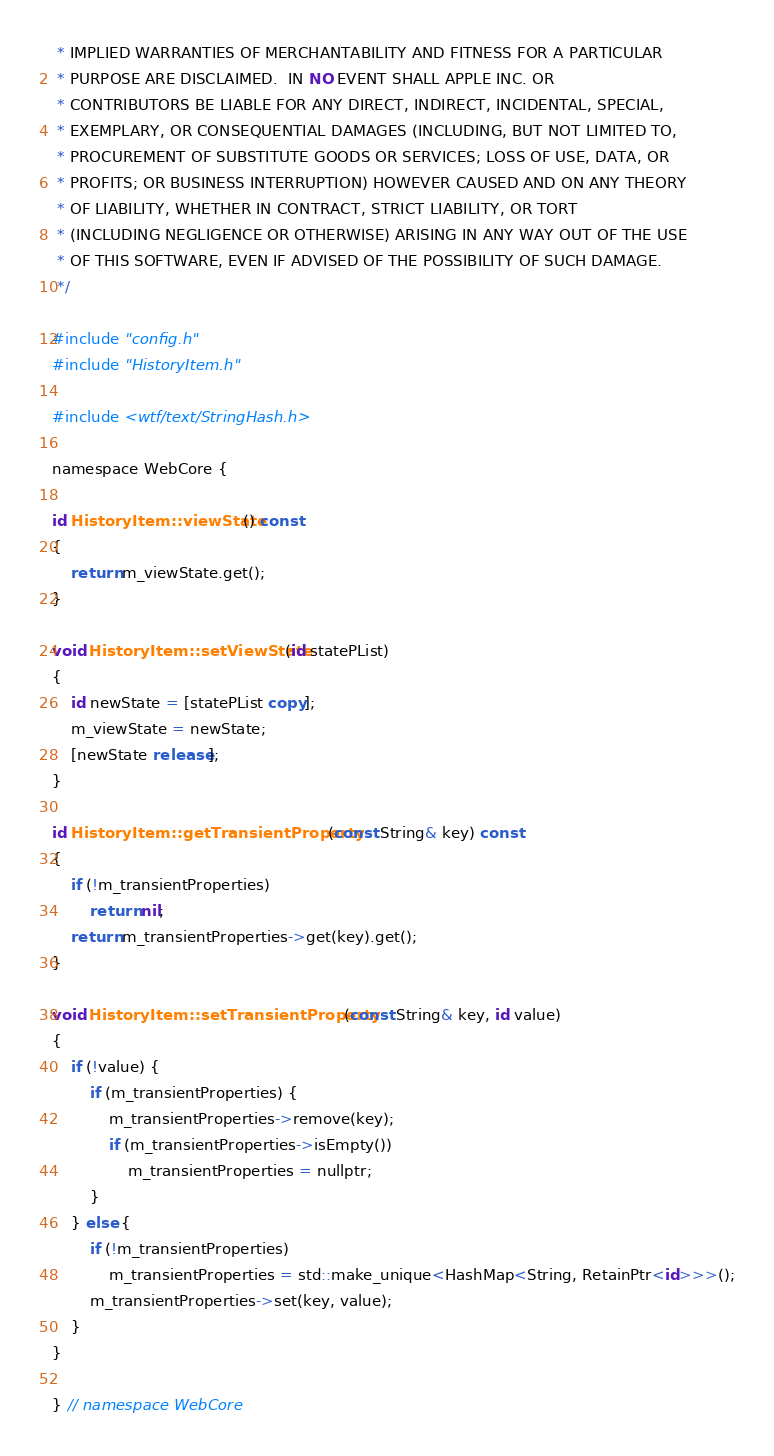<code> <loc_0><loc_0><loc_500><loc_500><_ObjectiveC_> * IMPLIED WARRANTIES OF MERCHANTABILITY AND FITNESS FOR A PARTICULAR
 * PURPOSE ARE DISCLAIMED.  IN NO EVENT SHALL APPLE INC. OR
 * CONTRIBUTORS BE LIABLE FOR ANY DIRECT, INDIRECT, INCIDENTAL, SPECIAL,
 * EXEMPLARY, OR CONSEQUENTIAL DAMAGES (INCLUDING, BUT NOT LIMITED TO,
 * PROCUREMENT OF SUBSTITUTE GOODS OR SERVICES; LOSS OF USE, DATA, OR
 * PROFITS; OR BUSINESS INTERRUPTION) HOWEVER CAUSED AND ON ANY THEORY
 * OF LIABILITY, WHETHER IN CONTRACT, STRICT LIABILITY, OR TORT
 * (INCLUDING NEGLIGENCE OR OTHERWISE) ARISING IN ANY WAY OUT OF THE USE
 * OF THIS SOFTWARE, EVEN IF ADVISED OF THE POSSIBILITY OF SUCH DAMAGE. 
 */

#include "config.h"
#include "HistoryItem.h"

#include <wtf/text/StringHash.h>

namespace WebCore {

id HistoryItem::viewState() const
{
    return m_viewState.get();
}

void HistoryItem::setViewState(id statePList)
{
    id newState = [statePList copy];
    m_viewState = newState;
    [newState release];
}

id HistoryItem::getTransientProperty(const String& key) const
{
    if (!m_transientProperties)
        return nil;
    return m_transientProperties->get(key).get();
}

void HistoryItem::setTransientProperty(const String& key, id value)
{
    if (!value) {
        if (m_transientProperties) {
            m_transientProperties->remove(key);
            if (m_transientProperties->isEmpty())
                m_transientProperties = nullptr;
        }
    } else {
        if (!m_transientProperties)
            m_transientProperties = std::make_unique<HashMap<String, RetainPtr<id>>>();
        m_transientProperties->set(key, value);
    }
}

} // namespace WebCore
</code> 